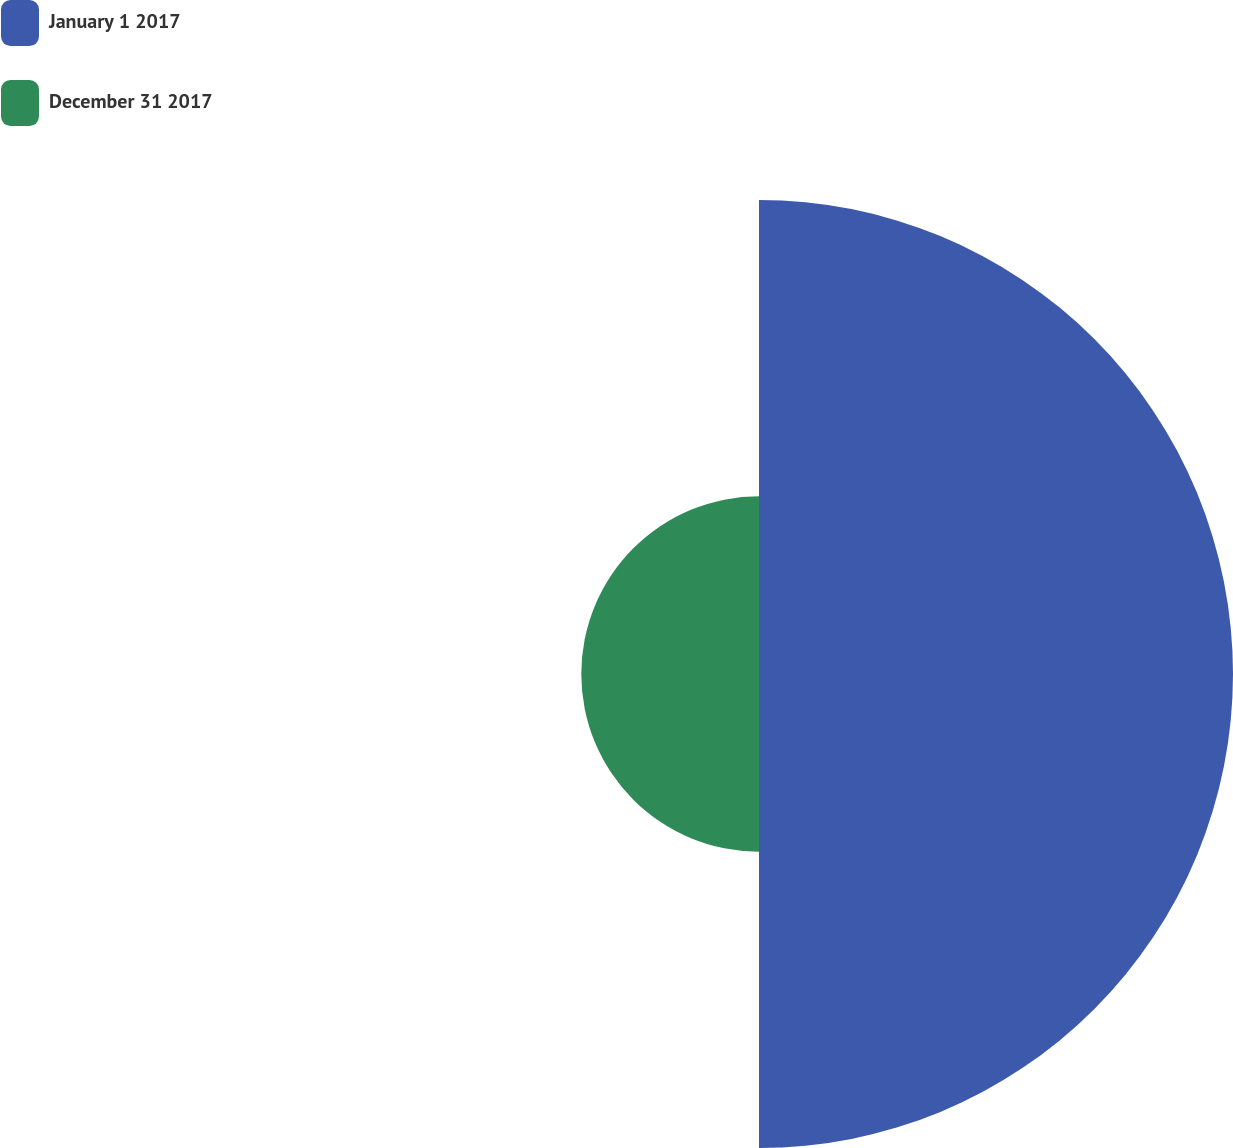Convert chart. <chart><loc_0><loc_0><loc_500><loc_500><pie_chart><fcel>January 1 2017<fcel>December 31 2017<nl><fcel>72.73%<fcel>27.27%<nl></chart> 